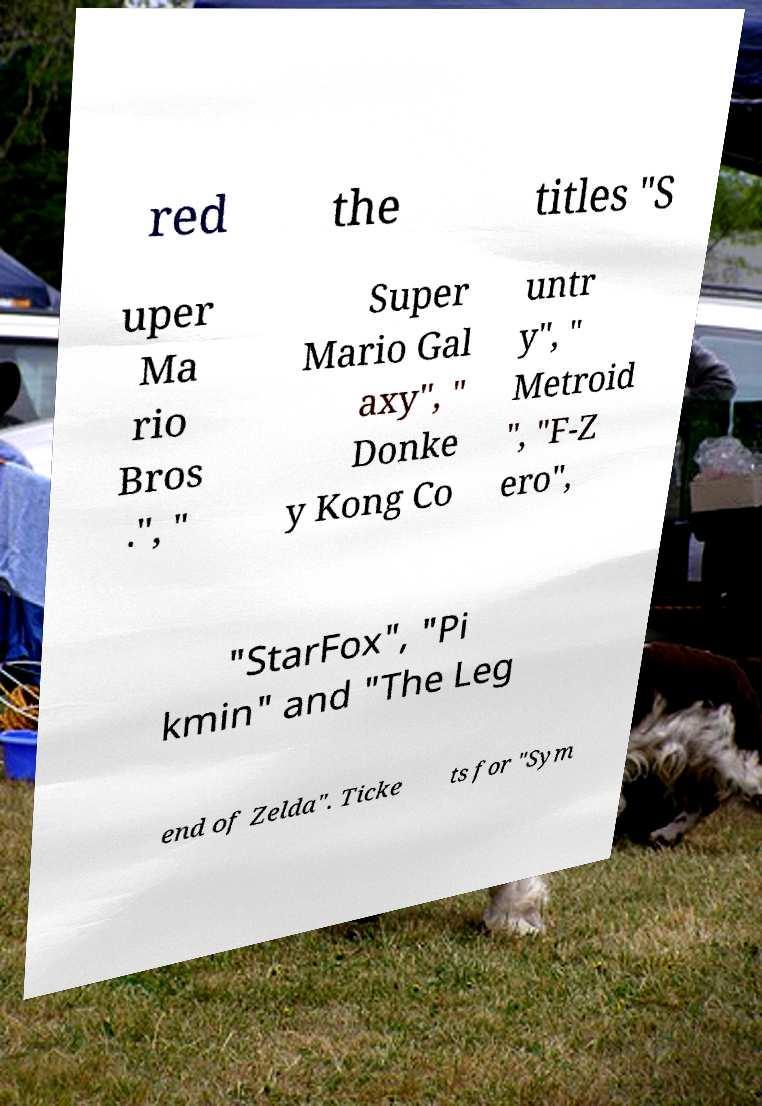What messages or text are displayed in this image? I need them in a readable, typed format. red the titles "S uper Ma rio Bros .", " Super Mario Gal axy", " Donke y Kong Co untr y", " Metroid ", "F-Z ero", "StarFox", "Pi kmin" and "The Leg end of Zelda". Ticke ts for "Sym 